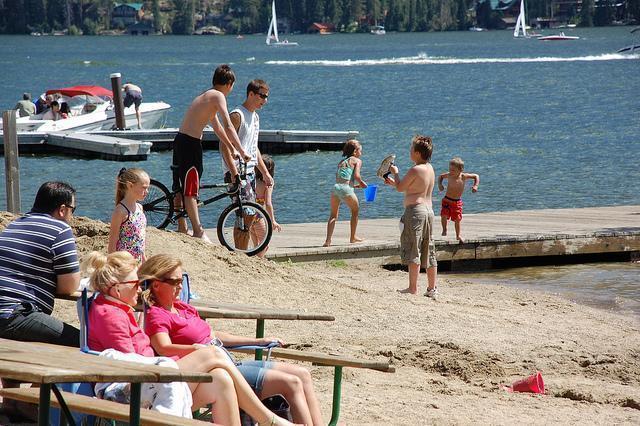Why is the boy holding up his shoe?
Make your selection and explain in format: 'Answer: answer
Rationale: rationale.'
Options: Disposing sand, avoiding water, beating people, tying shoe. Answer: disposing sand.
Rationale: When a person is wearing sneakers at the beach sand will get inside and they have to take off the shoe to shake it out. 